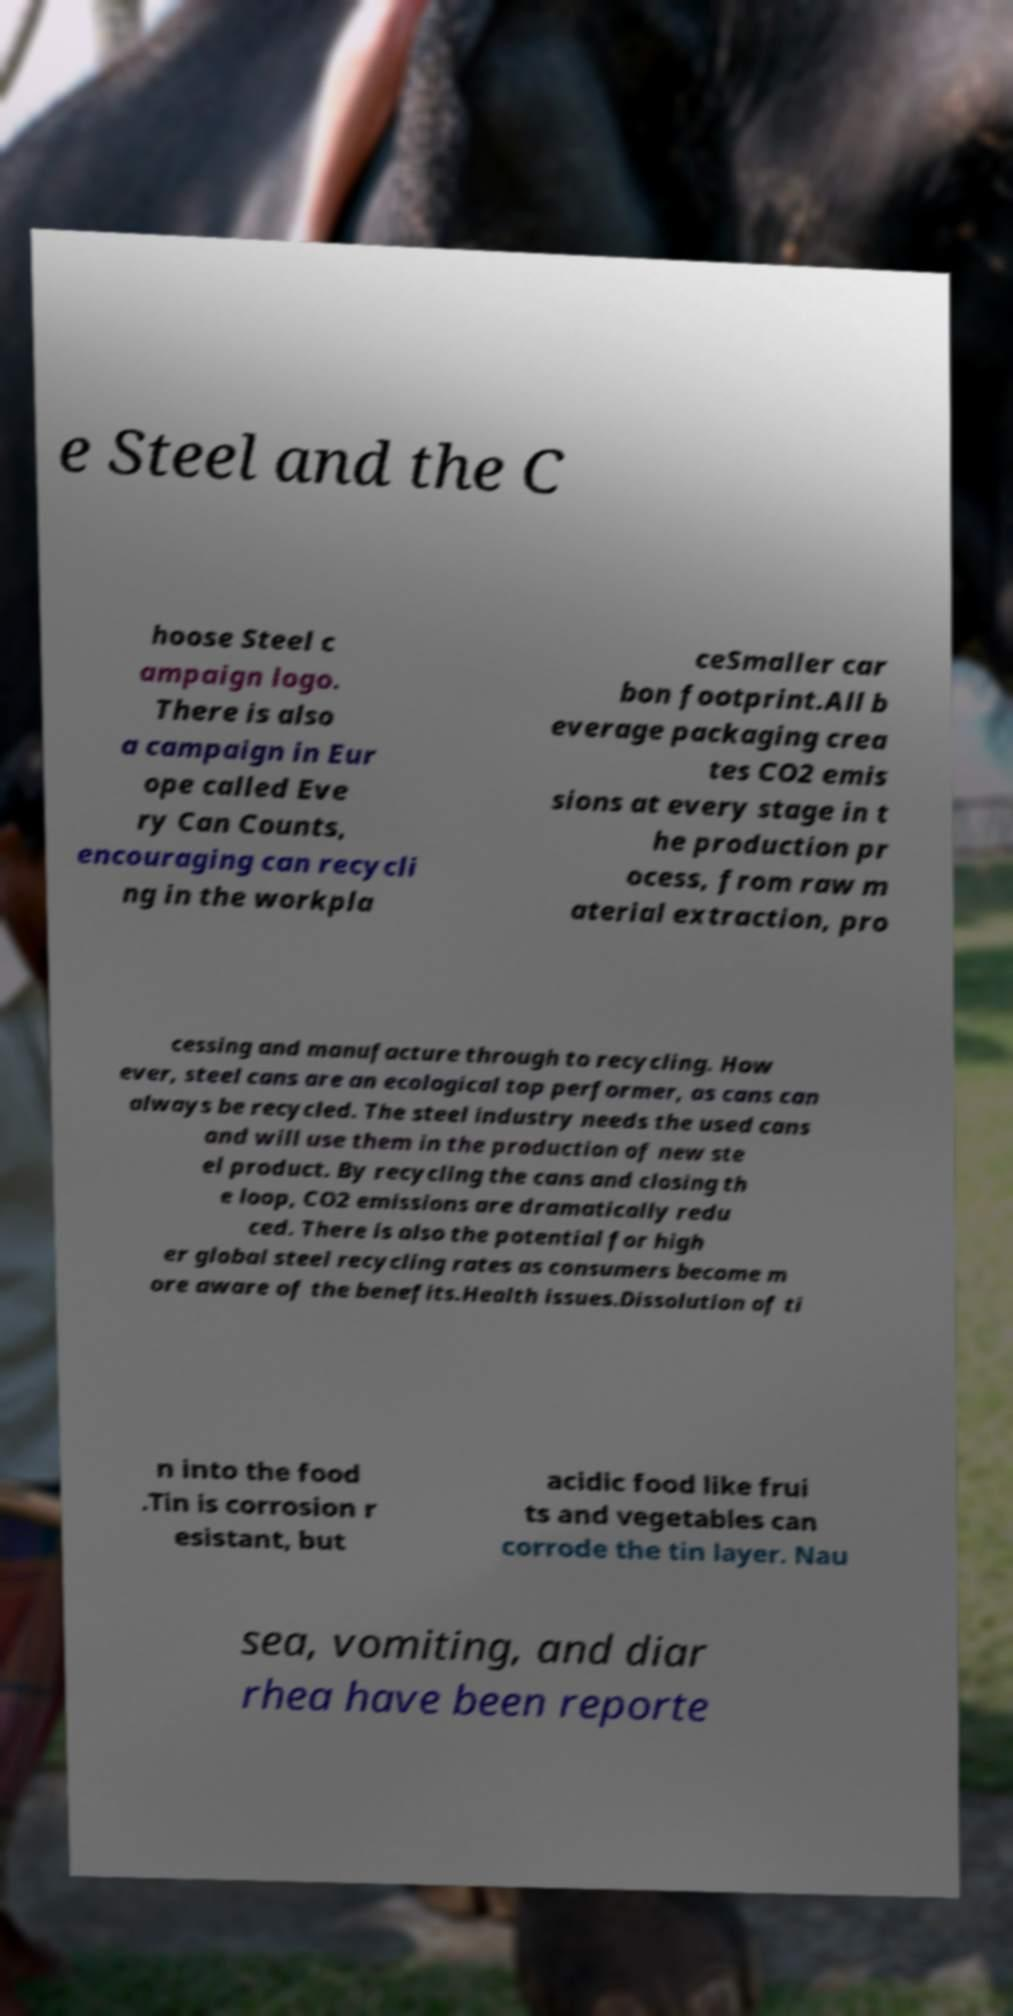Could you extract and type out the text from this image? e Steel and the C hoose Steel c ampaign logo. There is also a campaign in Eur ope called Eve ry Can Counts, encouraging can recycli ng in the workpla ceSmaller car bon footprint.All b everage packaging crea tes CO2 emis sions at every stage in t he production pr ocess, from raw m aterial extraction, pro cessing and manufacture through to recycling. How ever, steel cans are an ecological top performer, as cans can always be recycled. The steel industry needs the used cans and will use them in the production of new ste el product. By recycling the cans and closing th e loop, CO2 emissions are dramatically redu ced. There is also the potential for high er global steel recycling rates as consumers become m ore aware of the benefits.Health issues.Dissolution of ti n into the food .Tin is corrosion r esistant, but acidic food like frui ts and vegetables can corrode the tin layer. Nau sea, vomiting, and diar rhea have been reporte 